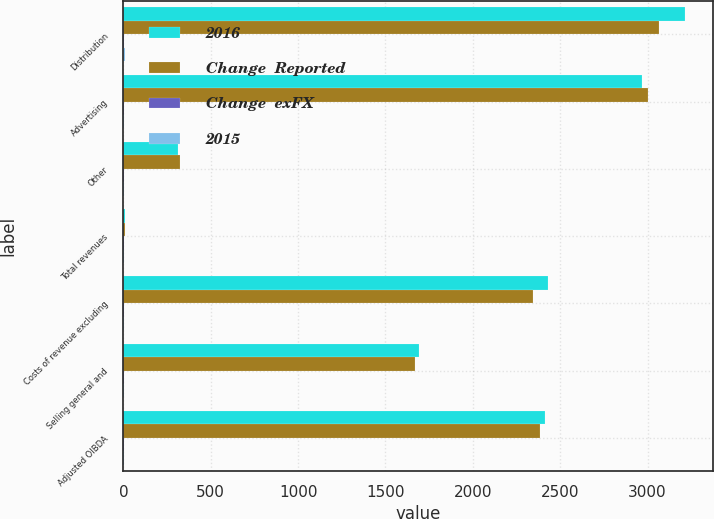Convert chart to OTSL. <chart><loc_0><loc_0><loc_500><loc_500><stacked_bar_chart><ecel><fcel>Distribution<fcel>Advertising<fcel>Other<fcel>Total revenues<fcel>Costs of revenue excluding<fcel>Selling general and<fcel>Adjusted OIBDA<nl><fcel>2016<fcel>3213<fcel>2970<fcel>314<fcel>7.5<fcel>2432<fcel>1690<fcel>2413<nl><fcel>Change  Reported<fcel>3068<fcel>3004<fcel>322<fcel>7.5<fcel>2343<fcel>1669<fcel>2382<nl><fcel>Change  exFX<fcel>5<fcel>1<fcel>2<fcel>2<fcel>4<fcel>1<fcel>1<nl><fcel>2015<fcel>9<fcel>1<fcel>2<fcel>4<fcel>6<fcel>4<fcel>5<nl></chart> 